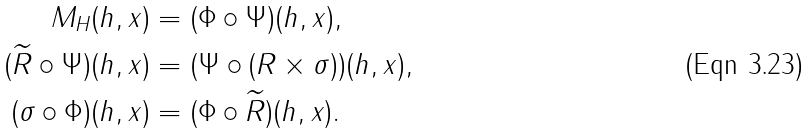<formula> <loc_0><loc_0><loc_500><loc_500>M _ { H } ( h , x ) & = ( \Phi \circ \Psi ) ( h , x ) , \\ ( \widetilde { R } \circ \Psi ) ( h , x ) & = ( \Psi \circ ( R \times \sigma ) ) ( h , x ) , \\ ( \sigma \circ \Phi ) ( h , x ) & = ( \Phi \circ \widetilde { R } ) ( h , x ) .</formula> 